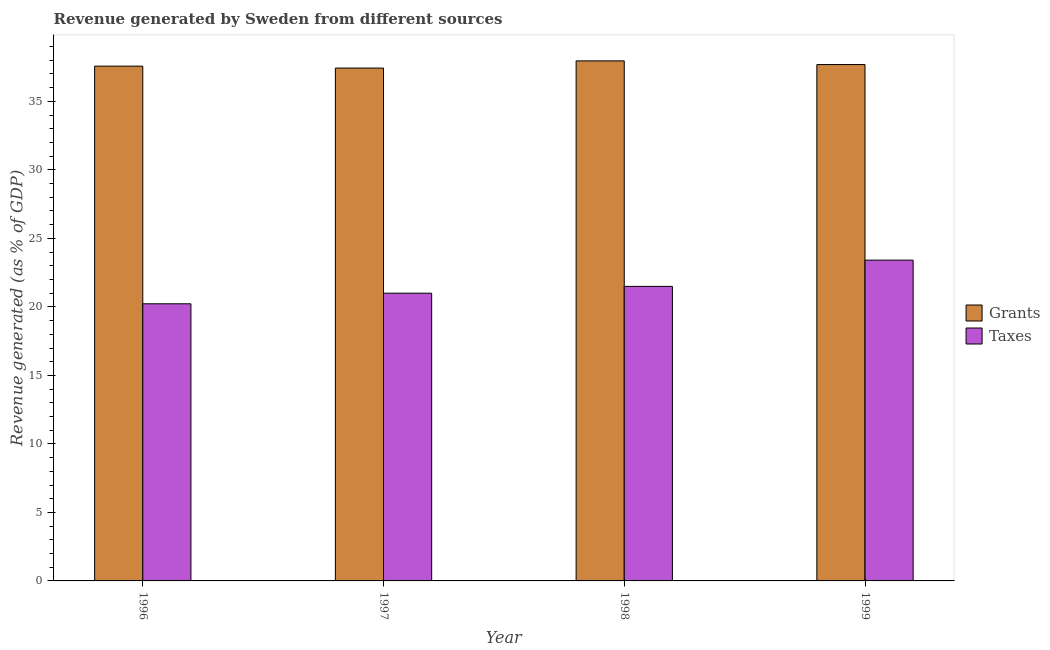Are the number of bars on each tick of the X-axis equal?
Your answer should be compact. Yes. How many bars are there on the 3rd tick from the left?
Your answer should be very brief. 2. How many bars are there on the 1st tick from the right?
Offer a terse response. 2. What is the revenue generated by grants in 1998?
Provide a short and direct response. 37.96. Across all years, what is the maximum revenue generated by taxes?
Offer a terse response. 23.41. Across all years, what is the minimum revenue generated by grants?
Make the answer very short. 37.43. In which year was the revenue generated by grants maximum?
Your response must be concise. 1998. In which year was the revenue generated by taxes minimum?
Give a very brief answer. 1996. What is the total revenue generated by grants in the graph?
Your answer should be very brief. 150.65. What is the difference between the revenue generated by grants in 1996 and that in 1997?
Provide a succinct answer. 0.14. What is the difference between the revenue generated by grants in 1996 and the revenue generated by taxes in 1997?
Your response must be concise. 0.14. What is the average revenue generated by grants per year?
Ensure brevity in your answer.  37.66. In the year 1999, what is the difference between the revenue generated by grants and revenue generated by taxes?
Keep it short and to the point. 0. What is the ratio of the revenue generated by grants in 1996 to that in 1997?
Ensure brevity in your answer.  1. Is the revenue generated by grants in 1998 less than that in 1999?
Your answer should be very brief. No. What is the difference between the highest and the second highest revenue generated by taxes?
Make the answer very short. 1.92. What is the difference between the highest and the lowest revenue generated by grants?
Offer a terse response. 0.53. In how many years, is the revenue generated by taxes greater than the average revenue generated by taxes taken over all years?
Your answer should be compact. 1. What does the 1st bar from the left in 1999 represents?
Your answer should be compact. Grants. What does the 2nd bar from the right in 1996 represents?
Ensure brevity in your answer.  Grants. How many bars are there?
Your response must be concise. 8. Are all the bars in the graph horizontal?
Give a very brief answer. No. How many years are there in the graph?
Give a very brief answer. 4. Does the graph contain grids?
Provide a short and direct response. No. What is the title of the graph?
Keep it short and to the point. Revenue generated by Sweden from different sources. Does "Non-solid fuel" appear as one of the legend labels in the graph?
Give a very brief answer. No. What is the label or title of the Y-axis?
Keep it short and to the point. Revenue generated (as % of GDP). What is the Revenue generated (as % of GDP) in Grants in 1996?
Offer a very short reply. 37.57. What is the Revenue generated (as % of GDP) in Taxes in 1996?
Give a very brief answer. 20.23. What is the Revenue generated (as % of GDP) of Grants in 1997?
Keep it short and to the point. 37.43. What is the Revenue generated (as % of GDP) of Taxes in 1997?
Make the answer very short. 21. What is the Revenue generated (as % of GDP) of Grants in 1998?
Your answer should be compact. 37.96. What is the Revenue generated (as % of GDP) of Taxes in 1998?
Keep it short and to the point. 21.5. What is the Revenue generated (as % of GDP) in Grants in 1999?
Offer a very short reply. 37.69. What is the Revenue generated (as % of GDP) in Taxes in 1999?
Your response must be concise. 23.41. Across all years, what is the maximum Revenue generated (as % of GDP) of Grants?
Provide a short and direct response. 37.96. Across all years, what is the maximum Revenue generated (as % of GDP) in Taxes?
Offer a very short reply. 23.41. Across all years, what is the minimum Revenue generated (as % of GDP) of Grants?
Your response must be concise. 37.43. Across all years, what is the minimum Revenue generated (as % of GDP) in Taxes?
Your answer should be compact. 20.23. What is the total Revenue generated (as % of GDP) in Grants in the graph?
Offer a terse response. 150.65. What is the total Revenue generated (as % of GDP) in Taxes in the graph?
Provide a succinct answer. 86.14. What is the difference between the Revenue generated (as % of GDP) in Grants in 1996 and that in 1997?
Give a very brief answer. 0.14. What is the difference between the Revenue generated (as % of GDP) in Taxes in 1996 and that in 1997?
Keep it short and to the point. -0.77. What is the difference between the Revenue generated (as % of GDP) in Grants in 1996 and that in 1998?
Give a very brief answer. -0.38. What is the difference between the Revenue generated (as % of GDP) of Taxes in 1996 and that in 1998?
Ensure brevity in your answer.  -1.27. What is the difference between the Revenue generated (as % of GDP) of Grants in 1996 and that in 1999?
Give a very brief answer. -0.11. What is the difference between the Revenue generated (as % of GDP) in Taxes in 1996 and that in 1999?
Provide a succinct answer. -3.19. What is the difference between the Revenue generated (as % of GDP) of Grants in 1997 and that in 1998?
Your response must be concise. -0.53. What is the difference between the Revenue generated (as % of GDP) of Taxes in 1997 and that in 1998?
Your answer should be very brief. -0.5. What is the difference between the Revenue generated (as % of GDP) of Grants in 1997 and that in 1999?
Make the answer very short. -0.26. What is the difference between the Revenue generated (as % of GDP) in Taxes in 1997 and that in 1999?
Provide a short and direct response. -2.41. What is the difference between the Revenue generated (as % of GDP) of Grants in 1998 and that in 1999?
Offer a terse response. 0.27. What is the difference between the Revenue generated (as % of GDP) of Taxes in 1998 and that in 1999?
Your answer should be compact. -1.92. What is the difference between the Revenue generated (as % of GDP) in Grants in 1996 and the Revenue generated (as % of GDP) in Taxes in 1997?
Offer a terse response. 16.57. What is the difference between the Revenue generated (as % of GDP) of Grants in 1996 and the Revenue generated (as % of GDP) of Taxes in 1998?
Keep it short and to the point. 16.08. What is the difference between the Revenue generated (as % of GDP) in Grants in 1996 and the Revenue generated (as % of GDP) in Taxes in 1999?
Ensure brevity in your answer.  14.16. What is the difference between the Revenue generated (as % of GDP) of Grants in 1997 and the Revenue generated (as % of GDP) of Taxes in 1998?
Keep it short and to the point. 15.94. What is the difference between the Revenue generated (as % of GDP) of Grants in 1997 and the Revenue generated (as % of GDP) of Taxes in 1999?
Your answer should be compact. 14.02. What is the difference between the Revenue generated (as % of GDP) of Grants in 1998 and the Revenue generated (as % of GDP) of Taxes in 1999?
Give a very brief answer. 14.54. What is the average Revenue generated (as % of GDP) of Grants per year?
Your response must be concise. 37.66. What is the average Revenue generated (as % of GDP) in Taxes per year?
Your answer should be very brief. 21.53. In the year 1996, what is the difference between the Revenue generated (as % of GDP) in Grants and Revenue generated (as % of GDP) in Taxes?
Offer a very short reply. 17.35. In the year 1997, what is the difference between the Revenue generated (as % of GDP) of Grants and Revenue generated (as % of GDP) of Taxes?
Your answer should be compact. 16.43. In the year 1998, what is the difference between the Revenue generated (as % of GDP) of Grants and Revenue generated (as % of GDP) of Taxes?
Your answer should be very brief. 16.46. In the year 1999, what is the difference between the Revenue generated (as % of GDP) of Grants and Revenue generated (as % of GDP) of Taxes?
Offer a very short reply. 14.27. What is the ratio of the Revenue generated (as % of GDP) of Grants in 1996 to that in 1997?
Ensure brevity in your answer.  1. What is the ratio of the Revenue generated (as % of GDP) in Taxes in 1996 to that in 1997?
Give a very brief answer. 0.96. What is the ratio of the Revenue generated (as % of GDP) of Taxes in 1996 to that in 1998?
Keep it short and to the point. 0.94. What is the ratio of the Revenue generated (as % of GDP) in Taxes in 1996 to that in 1999?
Give a very brief answer. 0.86. What is the ratio of the Revenue generated (as % of GDP) of Grants in 1997 to that in 1998?
Give a very brief answer. 0.99. What is the ratio of the Revenue generated (as % of GDP) in Taxes in 1997 to that in 1998?
Provide a short and direct response. 0.98. What is the ratio of the Revenue generated (as % of GDP) in Taxes in 1997 to that in 1999?
Provide a succinct answer. 0.9. What is the ratio of the Revenue generated (as % of GDP) of Grants in 1998 to that in 1999?
Offer a terse response. 1.01. What is the ratio of the Revenue generated (as % of GDP) in Taxes in 1998 to that in 1999?
Make the answer very short. 0.92. What is the difference between the highest and the second highest Revenue generated (as % of GDP) in Grants?
Give a very brief answer. 0.27. What is the difference between the highest and the second highest Revenue generated (as % of GDP) in Taxes?
Your answer should be compact. 1.92. What is the difference between the highest and the lowest Revenue generated (as % of GDP) of Grants?
Provide a short and direct response. 0.53. What is the difference between the highest and the lowest Revenue generated (as % of GDP) in Taxes?
Your answer should be very brief. 3.19. 